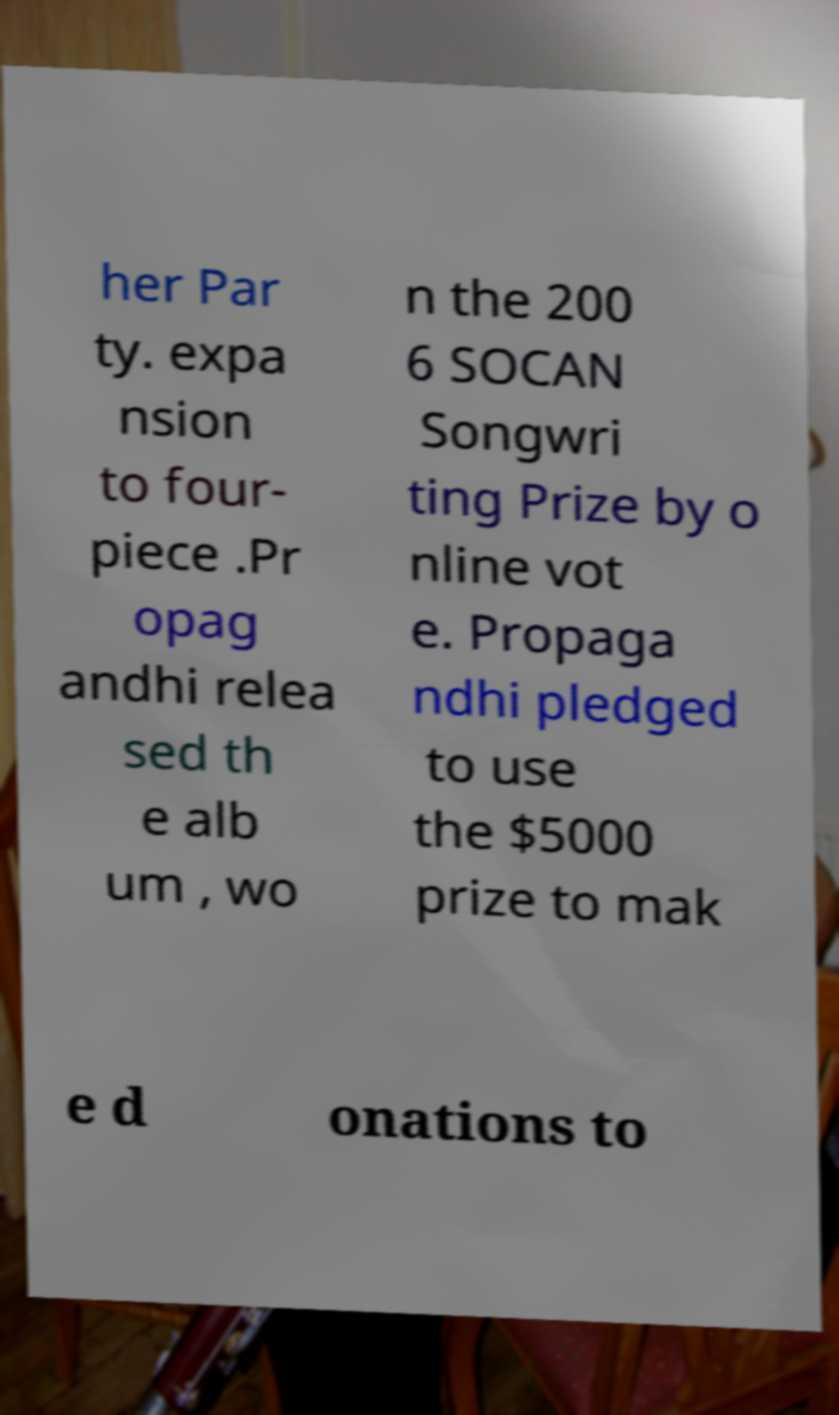I need the written content from this picture converted into text. Can you do that? her Par ty. expa nsion to four- piece .Pr opag andhi relea sed th e alb um , wo n the 200 6 SOCAN Songwri ting Prize by o nline vot e. Propaga ndhi pledged to use the $5000 prize to mak e d onations to 